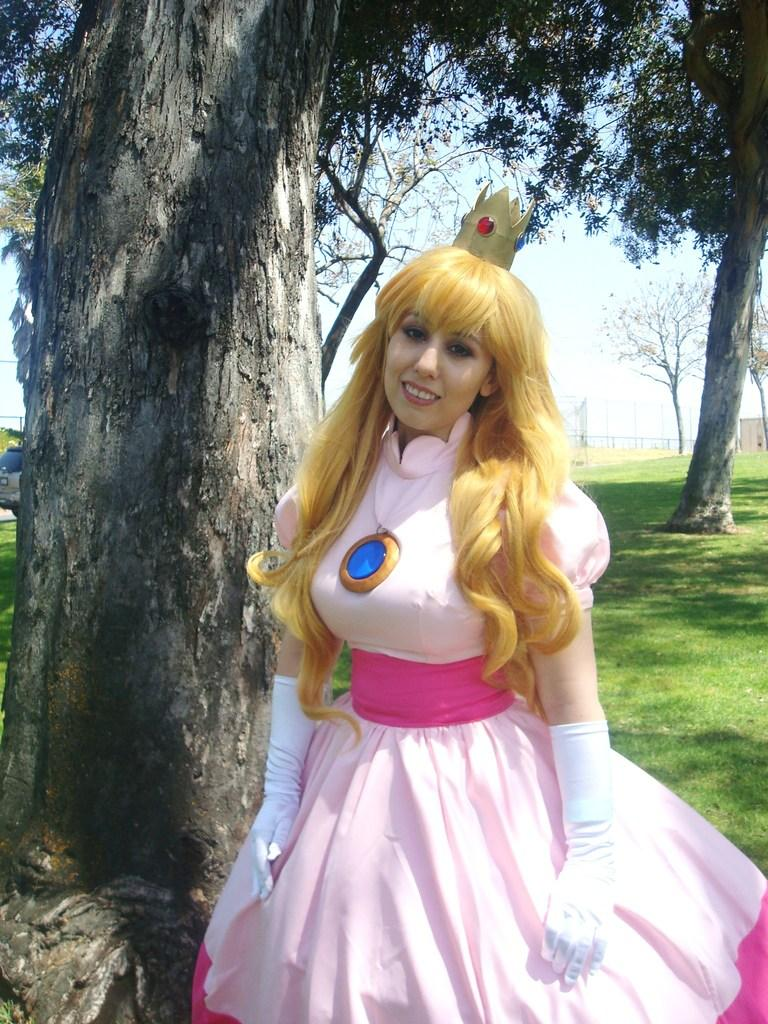Who is the main subject in the foreground of the image? There is a woman in the foreground of the image. What is the woman standing on? The woman is on the grass. What can be seen in the foreground of the image besides the woman? There are trees in the foreground of the image. What is visible in the background of the image? In the background of the image, there are fences, houses, a vehicle on the road, and the sky. Can you describe the setting of the image? The image may have been taken in a park, as there is grass, trees, and a vehicle on the road, which could suggest a public area. What type of hen can be seen sitting on the base in the image? There is no hen or base present in the image. How does the spark from the vehicle affect the woman in the image? There is no spark from the vehicle in the image, and therefore it cannot affect the woman. 